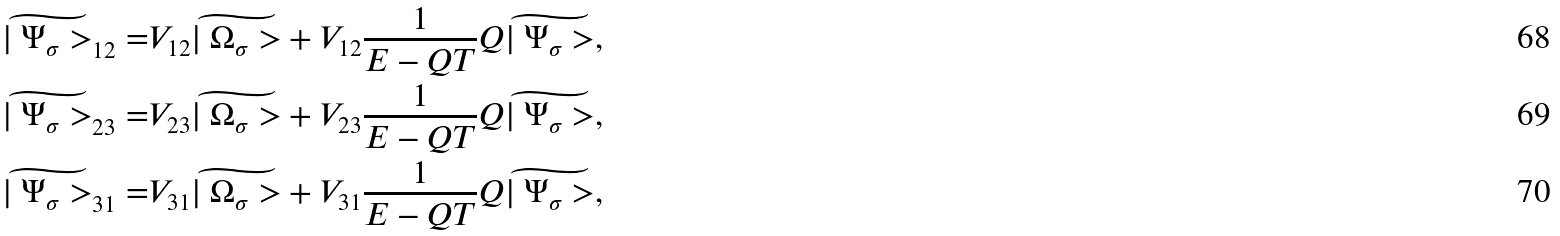<formula> <loc_0><loc_0><loc_500><loc_500>\widetilde { | \ \Psi _ { \sigma } > } _ { 1 2 } = & V _ { 1 2 } \widetilde { | \ \Omega _ { \sigma } > } + V _ { 1 2 } \frac { 1 } { E - Q T } Q \widetilde { | \ \Psi _ { \sigma } > } , \\ \widetilde { | \ \Psi _ { \sigma } > } _ { 2 3 } = & V _ { 2 3 } \widetilde { | \ \Omega _ { \sigma } > } + V _ { 2 3 } \frac { 1 } { E - Q T } Q \widetilde { | \ \Psi _ { \sigma } > } , \\ \widetilde { | \ \Psi _ { \sigma } > } _ { 3 1 } = & V _ { 3 1 } \widetilde { | \ \Omega _ { \sigma } > } + V _ { 3 1 } \frac { 1 } { E - Q T } Q \widetilde { | \ \Psi _ { \sigma } > } ,</formula> 